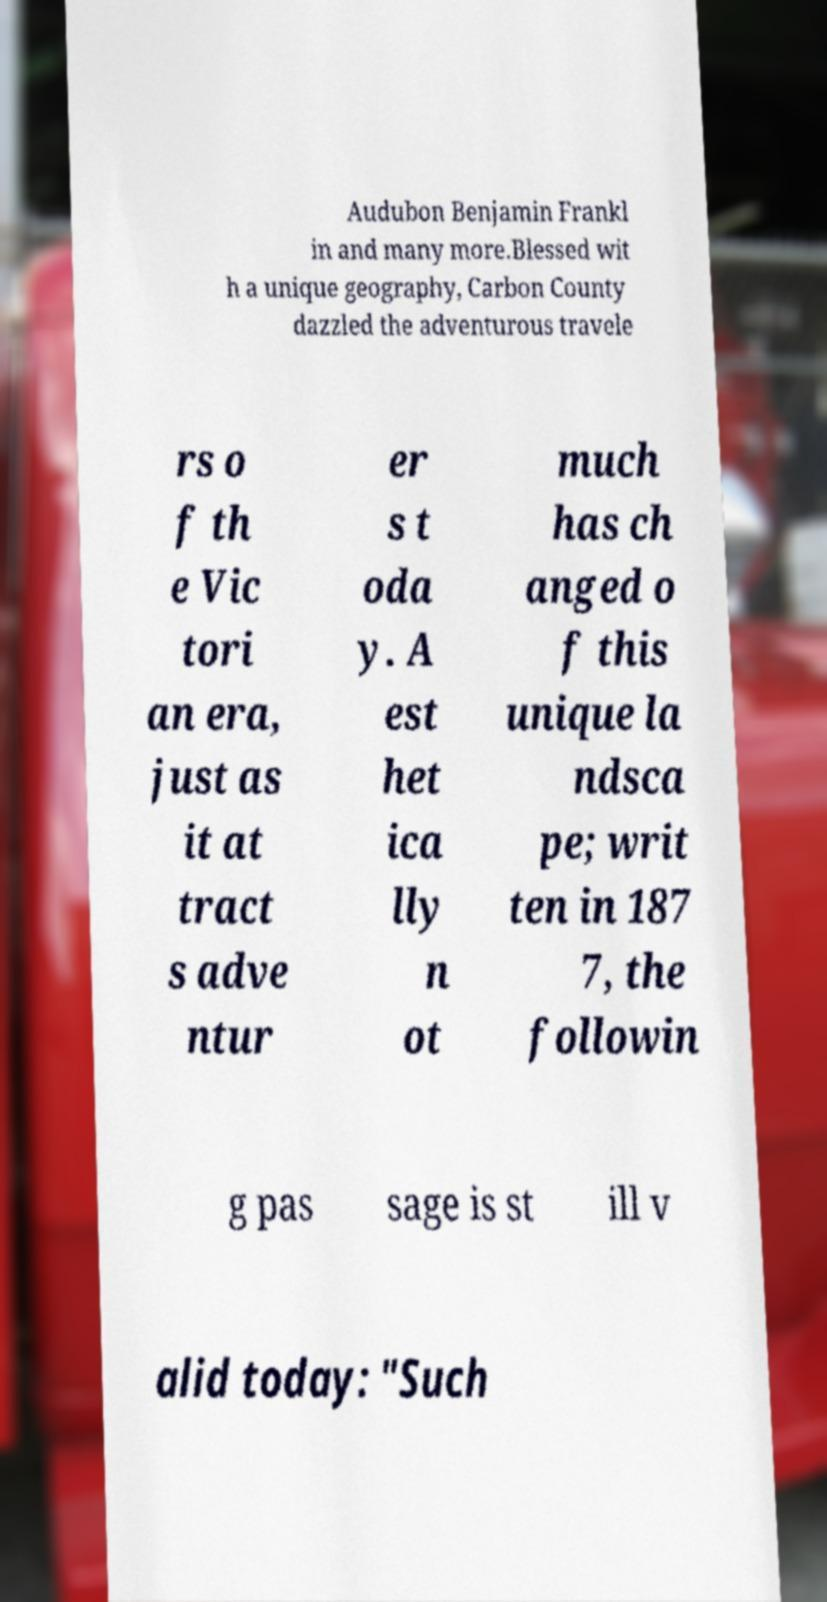I need the written content from this picture converted into text. Can you do that? Audubon Benjamin Frankl in and many more.Blessed wit h a unique geography, Carbon County dazzled the adventurous travele rs o f th e Vic tori an era, just as it at tract s adve ntur er s t oda y. A est het ica lly n ot much has ch anged o f this unique la ndsca pe; writ ten in 187 7, the followin g pas sage is st ill v alid today: "Such 